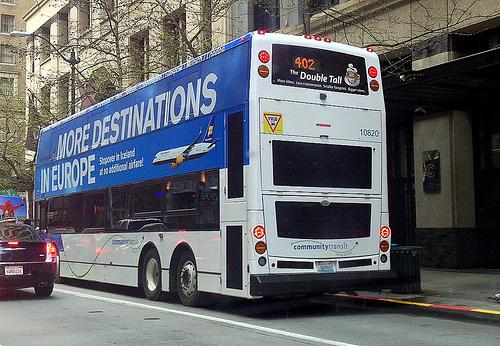Question: where is the bus?
Choices:
A. In a garage.
B. At the stoplight.
C. In the parking lot.
D. On road.
Answer with the letter. Answer: D Question: how many buses are shown?
Choices:
A. Two.
B. One.
C. Three.
D. Four.
Answer with the letter. Answer: B Question: what color is the road?
Choices:
A. Black.
B. Gray.
C. White.
D. Red.
Answer with the letter. Answer: B Question: how many levels are on bus?
Choices:
A. One.
B. Two.
C. Four.
D. Three.
Answer with the letter. Answer: B 